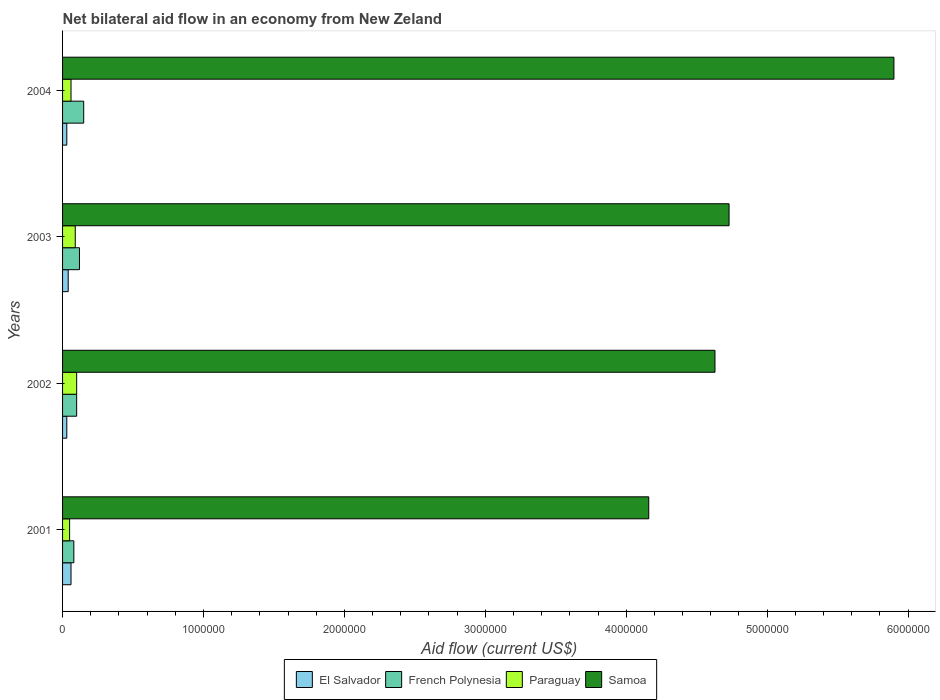How many groups of bars are there?
Your answer should be compact. 4. How many bars are there on the 3rd tick from the top?
Ensure brevity in your answer.  4. What is the label of the 2nd group of bars from the top?
Offer a very short reply. 2003. Across all years, what is the maximum net bilateral aid flow in Samoa?
Provide a succinct answer. 5.90e+06. In which year was the net bilateral aid flow in Samoa maximum?
Make the answer very short. 2004. What is the total net bilateral aid flow in Samoa in the graph?
Your answer should be compact. 1.94e+07. What is the difference between the net bilateral aid flow in Samoa in 2001 and that in 2004?
Make the answer very short. -1.74e+06. What is the average net bilateral aid flow in Samoa per year?
Your response must be concise. 4.86e+06. In the year 2002, what is the difference between the net bilateral aid flow in French Polynesia and net bilateral aid flow in Samoa?
Provide a short and direct response. -4.53e+06. In how many years, is the net bilateral aid flow in French Polynesia greater than 3000000 US$?
Make the answer very short. 0. What is the ratio of the net bilateral aid flow in El Salvador in 2001 to that in 2004?
Your answer should be compact. 2. In how many years, is the net bilateral aid flow in Paraguay greater than the average net bilateral aid flow in Paraguay taken over all years?
Give a very brief answer. 2. Is it the case that in every year, the sum of the net bilateral aid flow in Samoa and net bilateral aid flow in Paraguay is greater than the sum of net bilateral aid flow in El Salvador and net bilateral aid flow in French Polynesia?
Your answer should be compact. No. What does the 4th bar from the top in 2004 represents?
Give a very brief answer. El Salvador. What does the 4th bar from the bottom in 2002 represents?
Make the answer very short. Samoa. How many bars are there?
Your answer should be very brief. 16. Does the graph contain any zero values?
Your answer should be very brief. No. Where does the legend appear in the graph?
Offer a very short reply. Bottom center. How many legend labels are there?
Provide a short and direct response. 4. What is the title of the graph?
Keep it short and to the point. Net bilateral aid flow in an economy from New Zeland. What is the label or title of the X-axis?
Provide a succinct answer. Aid flow (current US$). What is the label or title of the Y-axis?
Give a very brief answer. Years. What is the Aid flow (current US$) of El Salvador in 2001?
Your answer should be very brief. 6.00e+04. What is the Aid flow (current US$) in Samoa in 2001?
Provide a succinct answer. 4.16e+06. What is the Aid flow (current US$) of El Salvador in 2002?
Give a very brief answer. 3.00e+04. What is the Aid flow (current US$) in French Polynesia in 2002?
Your answer should be compact. 1.00e+05. What is the Aid flow (current US$) in Paraguay in 2002?
Give a very brief answer. 1.00e+05. What is the Aid flow (current US$) of Samoa in 2002?
Offer a very short reply. 4.63e+06. What is the Aid flow (current US$) of El Salvador in 2003?
Offer a very short reply. 4.00e+04. What is the Aid flow (current US$) in French Polynesia in 2003?
Give a very brief answer. 1.20e+05. What is the Aid flow (current US$) of Samoa in 2003?
Offer a terse response. 4.73e+06. What is the Aid flow (current US$) in Samoa in 2004?
Keep it short and to the point. 5.90e+06. Across all years, what is the maximum Aid flow (current US$) of French Polynesia?
Your answer should be compact. 1.50e+05. Across all years, what is the maximum Aid flow (current US$) of Samoa?
Ensure brevity in your answer.  5.90e+06. Across all years, what is the minimum Aid flow (current US$) in Samoa?
Give a very brief answer. 4.16e+06. What is the total Aid flow (current US$) of El Salvador in the graph?
Ensure brevity in your answer.  1.60e+05. What is the total Aid flow (current US$) in French Polynesia in the graph?
Your answer should be very brief. 4.50e+05. What is the total Aid flow (current US$) in Paraguay in the graph?
Provide a succinct answer. 3.00e+05. What is the total Aid flow (current US$) in Samoa in the graph?
Offer a very short reply. 1.94e+07. What is the difference between the Aid flow (current US$) of French Polynesia in 2001 and that in 2002?
Offer a terse response. -2.00e+04. What is the difference between the Aid flow (current US$) in Samoa in 2001 and that in 2002?
Offer a terse response. -4.70e+05. What is the difference between the Aid flow (current US$) in El Salvador in 2001 and that in 2003?
Offer a terse response. 2.00e+04. What is the difference between the Aid flow (current US$) in Paraguay in 2001 and that in 2003?
Offer a terse response. -4.00e+04. What is the difference between the Aid flow (current US$) of Samoa in 2001 and that in 2003?
Keep it short and to the point. -5.70e+05. What is the difference between the Aid flow (current US$) in El Salvador in 2001 and that in 2004?
Keep it short and to the point. 3.00e+04. What is the difference between the Aid flow (current US$) of French Polynesia in 2001 and that in 2004?
Your answer should be very brief. -7.00e+04. What is the difference between the Aid flow (current US$) of Paraguay in 2001 and that in 2004?
Your answer should be very brief. -10000. What is the difference between the Aid flow (current US$) in Samoa in 2001 and that in 2004?
Make the answer very short. -1.74e+06. What is the difference between the Aid flow (current US$) in Paraguay in 2002 and that in 2003?
Your answer should be compact. 10000. What is the difference between the Aid flow (current US$) in El Salvador in 2002 and that in 2004?
Your answer should be compact. 0. What is the difference between the Aid flow (current US$) of French Polynesia in 2002 and that in 2004?
Keep it short and to the point. -5.00e+04. What is the difference between the Aid flow (current US$) of Samoa in 2002 and that in 2004?
Your answer should be compact. -1.27e+06. What is the difference between the Aid flow (current US$) of French Polynesia in 2003 and that in 2004?
Keep it short and to the point. -3.00e+04. What is the difference between the Aid flow (current US$) of Paraguay in 2003 and that in 2004?
Your answer should be compact. 3.00e+04. What is the difference between the Aid flow (current US$) in Samoa in 2003 and that in 2004?
Provide a succinct answer. -1.17e+06. What is the difference between the Aid flow (current US$) in El Salvador in 2001 and the Aid flow (current US$) in French Polynesia in 2002?
Keep it short and to the point. -4.00e+04. What is the difference between the Aid flow (current US$) in El Salvador in 2001 and the Aid flow (current US$) in Samoa in 2002?
Provide a short and direct response. -4.57e+06. What is the difference between the Aid flow (current US$) of French Polynesia in 2001 and the Aid flow (current US$) of Samoa in 2002?
Provide a short and direct response. -4.55e+06. What is the difference between the Aid flow (current US$) of Paraguay in 2001 and the Aid flow (current US$) of Samoa in 2002?
Your response must be concise. -4.58e+06. What is the difference between the Aid flow (current US$) in El Salvador in 2001 and the Aid flow (current US$) in French Polynesia in 2003?
Your response must be concise. -6.00e+04. What is the difference between the Aid flow (current US$) in El Salvador in 2001 and the Aid flow (current US$) in Samoa in 2003?
Provide a succinct answer. -4.67e+06. What is the difference between the Aid flow (current US$) of French Polynesia in 2001 and the Aid flow (current US$) of Paraguay in 2003?
Give a very brief answer. -10000. What is the difference between the Aid flow (current US$) in French Polynesia in 2001 and the Aid flow (current US$) in Samoa in 2003?
Ensure brevity in your answer.  -4.65e+06. What is the difference between the Aid flow (current US$) in Paraguay in 2001 and the Aid flow (current US$) in Samoa in 2003?
Your response must be concise. -4.68e+06. What is the difference between the Aid flow (current US$) of El Salvador in 2001 and the Aid flow (current US$) of Paraguay in 2004?
Ensure brevity in your answer.  0. What is the difference between the Aid flow (current US$) in El Salvador in 2001 and the Aid flow (current US$) in Samoa in 2004?
Your answer should be very brief. -5.84e+06. What is the difference between the Aid flow (current US$) in French Polynesia in 2001 and the Aid flow (current US$) in Samoa in 2004?
Your answer should be very brief. -5.82e+06. What is the difference between the Aid flow (current US$) of Paraguay in 2001 and the Aid flow (current US$) of Samoa in 2004?
Offer a terse response. -5.85e+06. What is the difference between the Aid flow (current US$) in El Salvador in 2002 and the Aid flow (current US$) in Paraguay in 2003?
Offer a very short reply. -6.00e+04. What is the difference between the Aid flow (current US$) of El Salvador in 2002 and the Aid flow (current US$) of Samoa in 2003?
Provide a succinct answer. -4.70e+06. What is the difference between the Aid flow (current US$) of French Polynesia in 2002 and the Aid flow (current US$) of Paraguay in 2003?
Ensure brevity in your answer.  10000. What is the difference between the Aid flow (current US$) in French Polynesia in 2002 and the Aid flow (current US$) in Samoa in 2003?
Offer a very short reply. -4.63e+06. What is the difference between the Aid flow (current US$) of Paraguay in 2002 and the Aid flow (current US$) of Samoa in 2003?
Give a very brief answer. -4.63e+06. What is the difference between the Aid flow (current US$) in El Salvador in 2002 and the Aid flow (current US$) in Samoa in 2004?
Ensure brevity in your answer.  -5.87e+06. What is the difference between the Aid flow (current US$) of French Polynesia in 2002 and the Aid flow (current US$) of Paraguay in 2004?
Make the answer very short. 4.00e+04. What is the difference between the Aid flow (current US$) of French Polynesia in 2002 and the Aid flow (current US$) of Samoa in 2004?
Ensure brevity in your answer.  -5.80e+06. What is the difference between the Aid flow (current US$) in Paraguay in 2002 and the Aid flow (current US$) in Samoa in 2004?
Give a very brief answer. -5.80e+06. What is the difference between the Aid flow (current US$) in El Salvador in 2003 and the Aid flow (current US$) in Samoa in 2004?
Offer a very short reply. -5.86e+06. What is the difference between the Aid flow (current US$) of French Polynesia in 2003 and the Aid flow (current US$) of Paraguay in 2004?
Your answer should be compact. 6.00e+04. What is the difference between the Aid flow (current US$) in French Polynesia in 2003 and the Aid flow (current US$) in Samoa in 2004?
Provide a short and direct response. -5.78e+06. What is the difference between the Aid flow (current US$) in Paraguay in 2003 and the Aid flow (current US$) in Samoa in 2004?
Your answer should be very brief. -5.81e+06. What is the average Aid flow (current US$) in French Polynesia per year?
Offer a very short reply. 1.12e+05. What is the average Aid flow (current US$) in Paraguay per year?
Offer a very short reply. 7.50e+04. What is the average Aid flow (current US$) of Samoa per year?
Provide a succinct answer. 4.86e+06. In the year 2001, what is the difference between the Aid flow (current US$) in El Salvador and Aid flow (current US$) in Paraguay?
Give a very brief answer. 10000. In the year 2001, what is the difference between the Aid flow (current US$) of El Salvador and Aid flow (current US$) of Samoa?
Your answer should be compact. -4.10e+06. In the year 2001, what is the difference between the Aid flow (current US$) of French Polynesia and Aid flow (current US$) of Paraguay?
Keep it short and to the point. 3.00e+04. In the year 2001, what is the difference between the Aid flow (current US$) of French Polynesia and Aid flow (current US$) of Samoa?
Make the answer very short. -4.08e+06. In the year 2001, what is the difference between the Aid flow (current US$) in Paraguay and Aid flow (current US$) in Samoa?
Give a very brief answer. -4.11e+06. In the year 2002, what is the difference between the Aid flow (current US$) in El Salvador and Aid flow (current US$) in French Polynesia?
Your answer should be compact. -7.00e+04. In the year 2002, what is the difference between the Aid flow (current US$) in El Salvador and Aid flow (current US$) in Samoa?
Make the answer very short. -4.60e+06. In the year 2002, what is the difference between the Aid flow (current US$) of French Polynesia and Aid flow (current US$) of Paraguay?
Make the answer very short. 0. In the year 2002, what is the difference between the Aid flow (current US$) of French Polynesia and Aid flow (current US$) of Samoa?
Make the answer very short. -4.53e+06. In the year 2002, what is the difference between the Aid flow (current US$) of Paraguay and Aid flow (current US$) of Samoa?
Your response must be concise. -4.53e+06. In the year 2003, what is the difference between the Aid flow (current US$) of El Salvador and Aid flow (current US$) of Samoa?
Offer a terse response. -4.69e+06. In the year 2003, what is the difference between the Aid flow (current US$) in French Polynesia and Aid flow (current US$) in Samoa?
Provide a succinct answer. -4.61e+06. In the year 2003, what is the difference between the Aid flow (current US$) in Paraguay and Aid flow (current US$) in Samoa?
Your response must be concise. -4.64e+06. In the year 2004, what is the difference between the Aid flow (current US$) in El Salvador and Aid flow (current US$) in Samoa?
Provide a short and direct response. -5.87e+06. In the year 2004, what is the difference between the Aid flow (current US$) in French Polynesia and Aid flow (current US$) in Samoa?
Your answer should be compact. -5.75e+06. In the year 2004, what is the difference between the Aid flow (current US$) in Paraguay and Aid flow (current US$) in Samoa?
Offer a very short reply. -5.84e+06. What is the ratio of the Aid flow (current US$) in El Salvador in 2001 to that in 2002?
Give a very brief answer. 2. What is the ratio of the Aid flow (current US$) of Paraguay in 2001 to that in 2002?
Provide a short and direct response. 0.5. What is the ratio of the Aid flow (current US$) in Samoa in 2001 to that in 2002?
Make the answer very short. 0.9. What is the ratio of the Aid flow (current US$) in French Polynesia in 2001 to that in 2003?
Your answer should be very brief. 0.67. What is the ratio of the Aid flow (current US$) of Paraguay in 2001 to that in 2003?
Provide a short and direct response. 0.56. What is the ratio of the Aid flow (current US$) of Samoa in 2001 to that in 2003?
Your answer should be very brief. 0.88. What is the ratio of the Aid flow (current US$) in El Salvador in 2001 to that in 2004?
Your response must be concise. 2. What is the ratio of the Aid flow (current US$) in French Polynesia in 2001 to that in 2004?
Offer a very short reply. 0.53. What is the ratio of the Aid flow (current US$) in Paraguay in 2001 to that in 2004?
Offer a terse response. 0.83. What is the ratio of the Aid flow (current US$) of Samoa in 2001 to that in 2004?
Ensure brevity in your answer.  0.71. What is the ratio of the Aid flow (current US$) of French Polynesia in 2002 to that in 2003?
Your answer should be very brief. 0.83. What is the ratio of the Aid flow (current US$) in Samoa in 2002 to that in 2003?
Your response must be concise. 0.98. What is the ratio of the Aid flow (current US$) in Samoa in 2002 to that in 2004?
Make the answer very short. 0.78. What is the ratio of the Aid flow (current US$) in El Salvador in 2003 to that in 2004?
Offer a terse response. 1.33. What is the ratio of the Aid flow (current US$) in Samoa in 2003 to that in 2004?
Your answer should be compact. 0.8. What is the difference between the highest and the second highest Aid flow (current US$) in El Salvador?
Give a very brief answer. 2.00e+04. What is the difference between the highest and the second highest Aid flow (current US$) of Paraguay?
Ensure brevity in your answer.  10000. What is the difference between the highest and the second highest Aid flow (current US$) in Samoa?
Your response must be concise. 1.17e+06. What is the difference between the highest and the lowest Aid flow (current US$) in El Salvador?
Make the answer very short. 3.00e+04. What is the difference between the highest and the lowest Aid flow (current US$) in French Polynesia?
Ensure brevity in your answer.  7.00e+04. What is the difference between the highest and the lowest Aid flow (current US$) in Paraguay?
Provide a succinct answer. 5.00e+04. What is the difference between the highest and the lowest Aid flow (current US$) in Samoa?
Keep it short and to the point. 1.74e+06. 